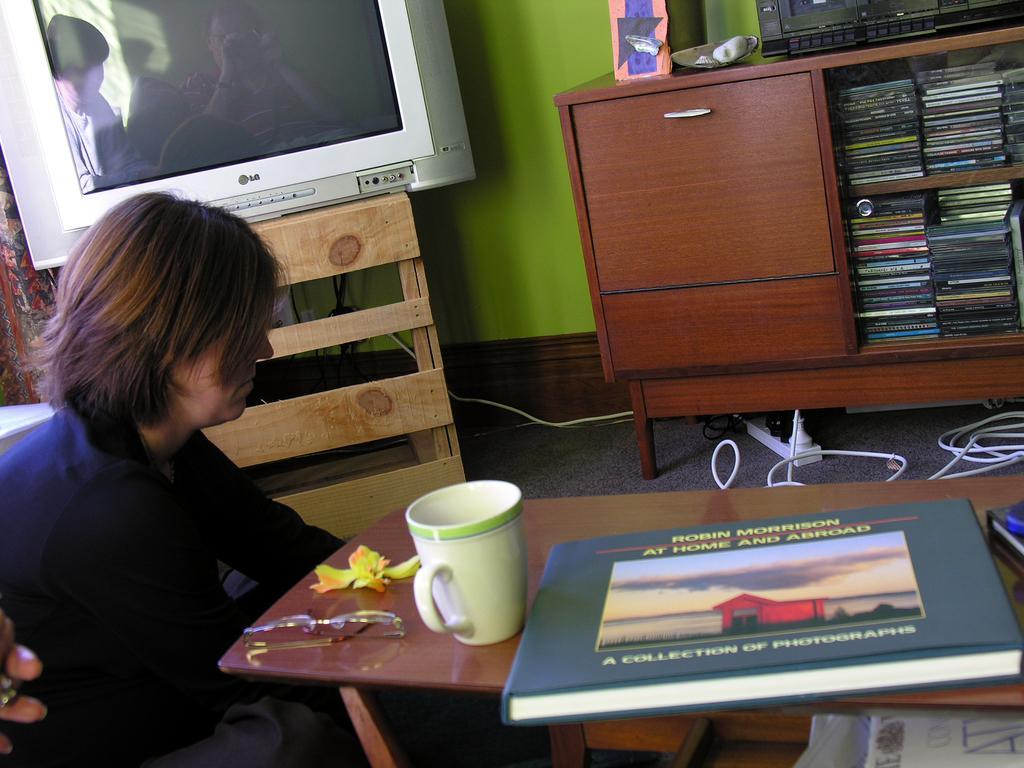Describe this image in one or two sentences. In this picture there is a person sitting on the floor, there is a table in front of her. It has spectacles, a coffee mug, book. In the background there is a television, some compact disc, and some cables on the floor and there is a green color wall. 